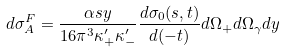Convert formula to latex. <formula><loc_0><loc_0><loc_500><loc_500>d \sigma _ { A } ^ { F } = \frac { \alpha s y } { 1 6 \pi ^ { 3 } \kappa ^ { \prime } _ { + } \kappa ^ { \prime } _ { - } } \frac { d \sigma _ { 0 } ( s , t ) } { d ( - t ) } d \Omega _ { + } d \Omega _ { \gamma } d y</formula> 